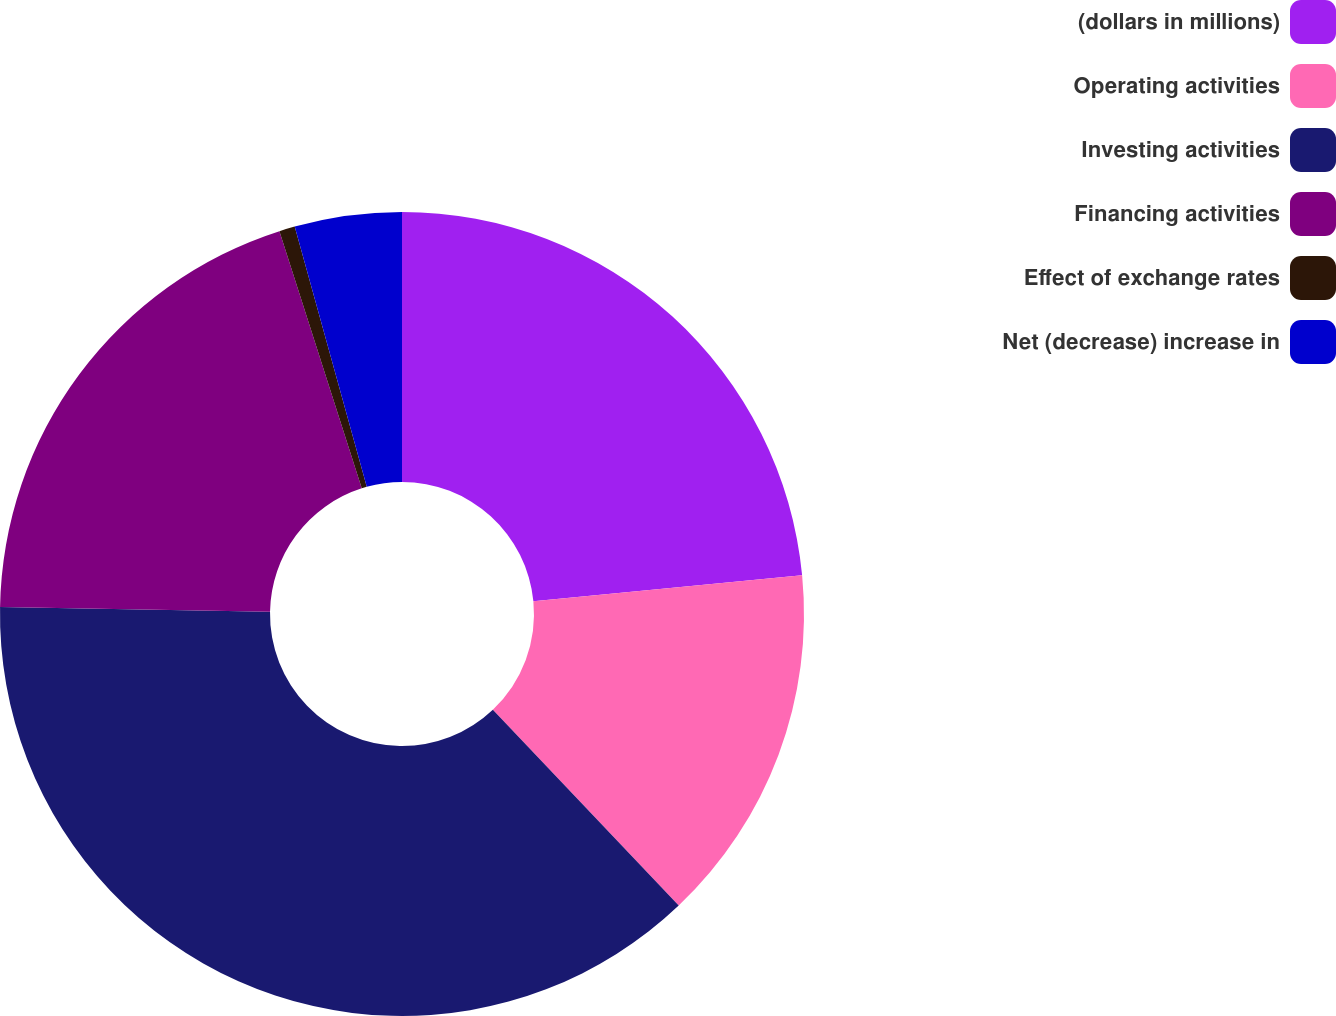<chart> <loc_0><loc_0><loc_500><loc_500><pie_chart><fcel>(dollars in millions)<fcel>Operating activities<fcel>Investing activities<fcel>Financing activities<fcel>Effect of exchange rates<fcel>Net (decrease) increase in<nl><fcel>23.46%<fcel>14.45%<fcel>37.35%<fcel>19.79%<fcel>0.63%<fcel>4.3%<nl></chart> 